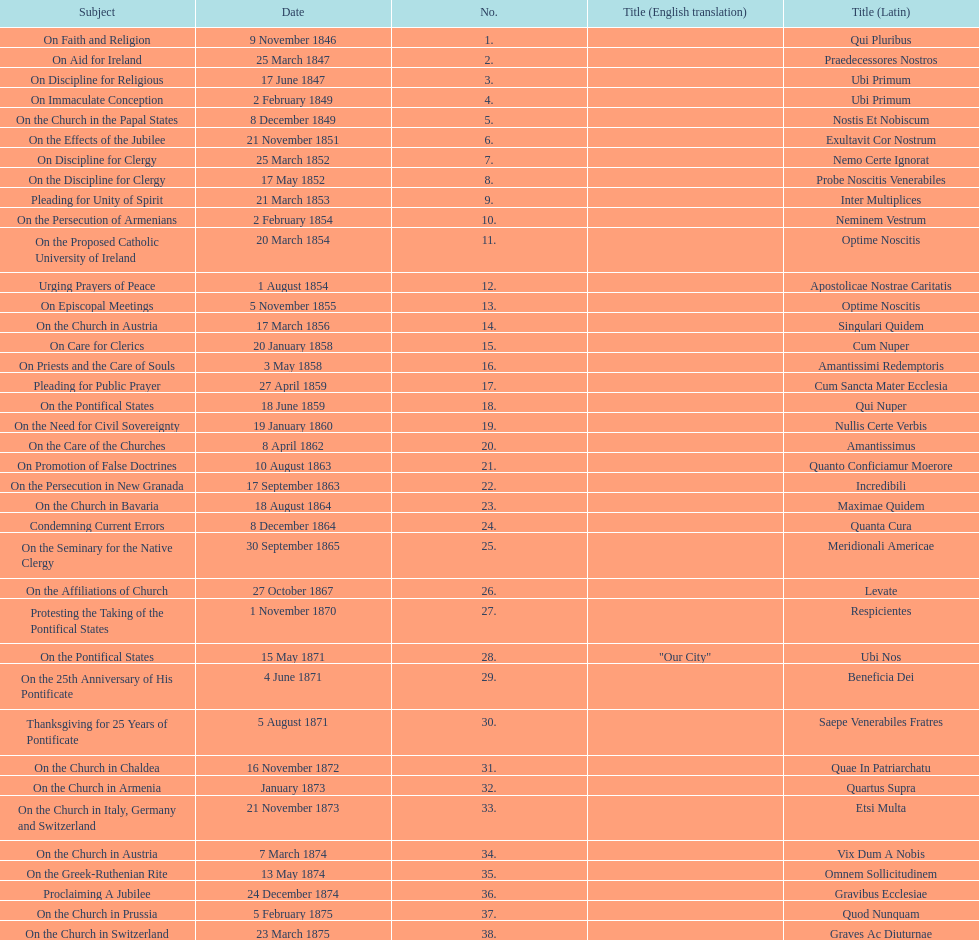Total number of encyclicals on churches . 11. 